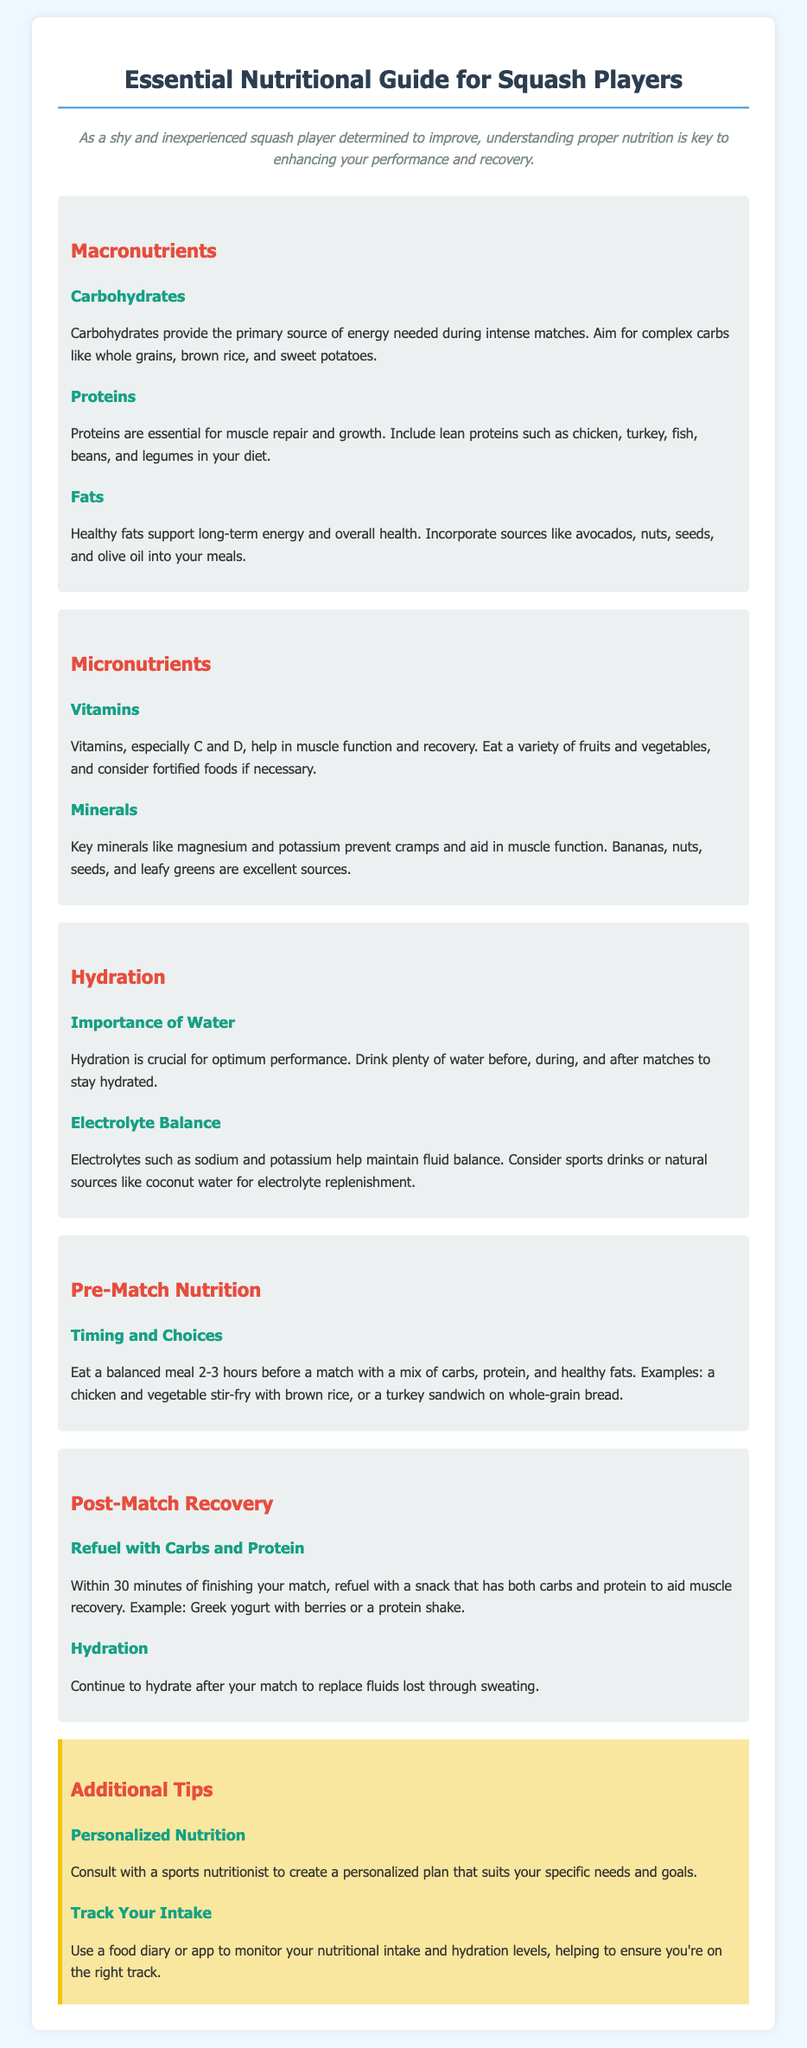What is the primary source of energy for squash players? The primary source of energy needed during intense matches is carbohydrates.
Answer: Carbohydrates Which macronutrient is essential for muscle repair? Proteins play a crucial role in muscle repair and growth.
Answer: Proteins What vitamins are highlighted for muscle function? Vitamins C and D are specifically mentioned for their importance in muscle function and recovery.
Answer: C and D How long before a match should players eat a balanced meal? Players should eat a balanced meal 2-3 hours before a match.
Answer: 2-3 hours What should be consumed within 30 minutes after a match? A snack that has both carbs and protein should be consumed within 30 minutes after a match.
Answer: Carbs and protein What is vital for maintaining fluid balance? Electrolytes such as sodium and potassium are essential for maintaining fluid balance.
Answer: Electrolytes What type of drink may help with electrolyte replenishment? Sports drinks or natural sources like coconut water may help with electrolyte replenishment.
Answer: Sports drinks What is recommended for personalized nutrition? Consulting with a sports nutritionist is recommended for personalized nutrition.
Answer: Sports nutritionist What should players use to monitor nutritional intake and hydration? Players should use a food diary or app to monitor their nutritional intake and hydration levels.
Answer: Food diary or app 